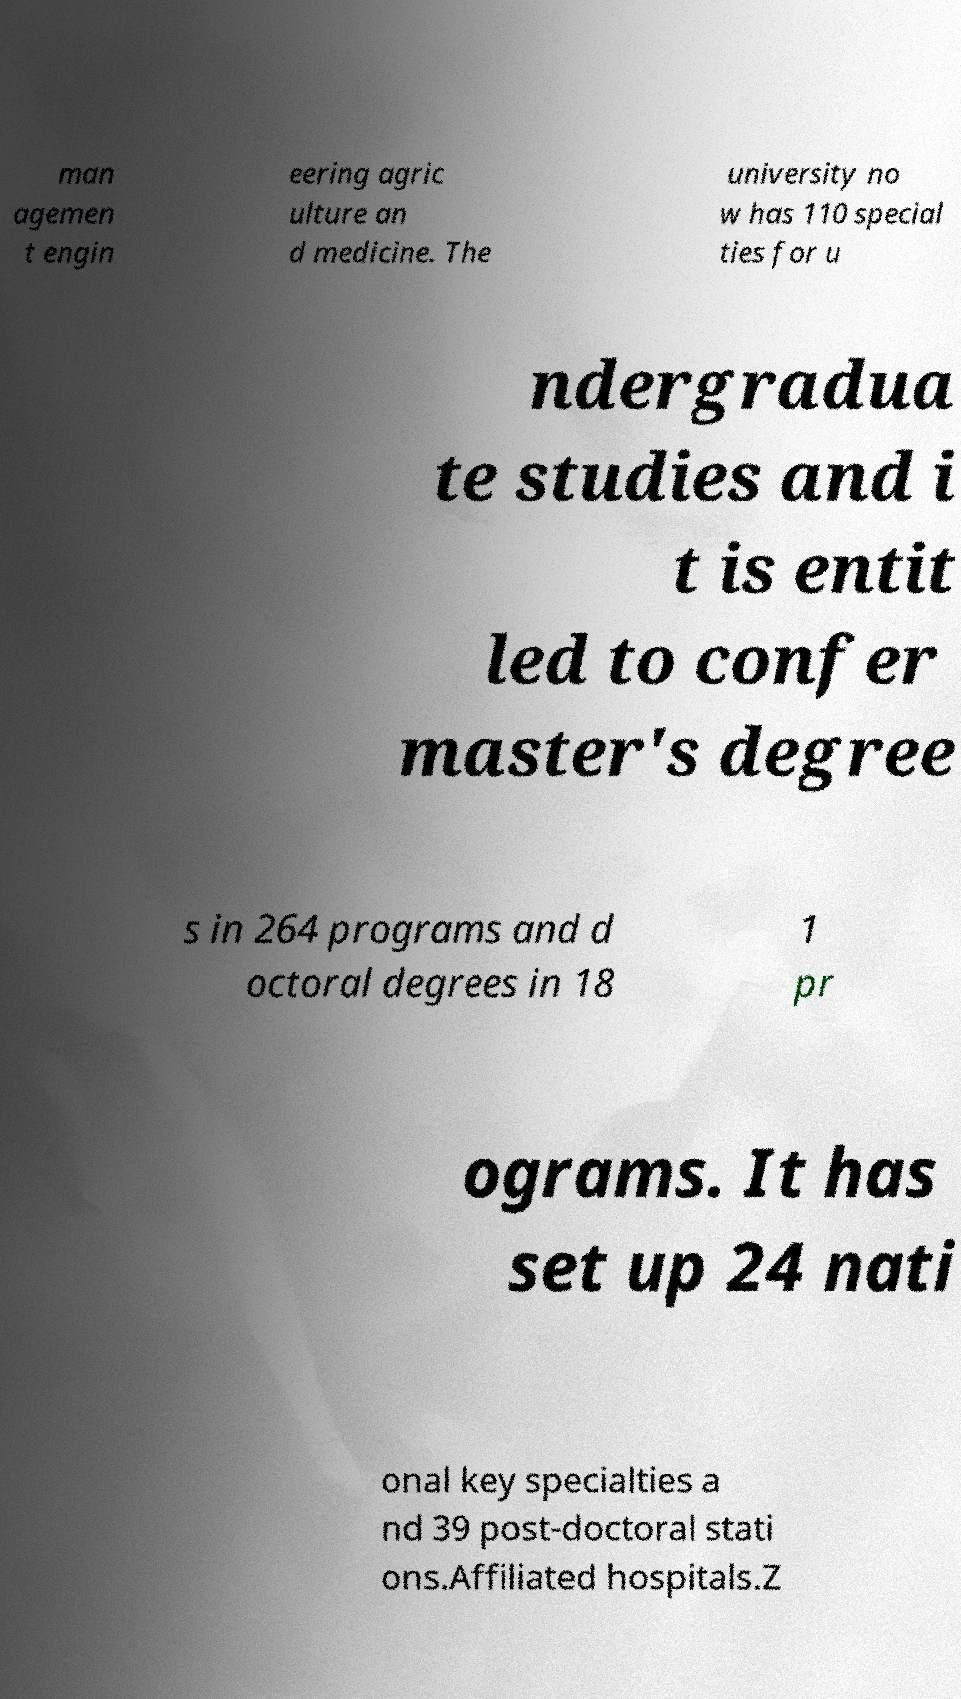There's text embedded in this image that I need extracted. Can you transcribe it verbatim? man agemen t engin eering agric ulture an d medicine. The university no w has 110 special ties for u ndergradua te studies and i t is entit led to confer master's degree s in 264 programs and d octoral degrees in 18 1 pr ograms. It has set up 24 nati onal key specialties a nd 39 post-doctoral stati ons.Affiliated hospitals.Z 